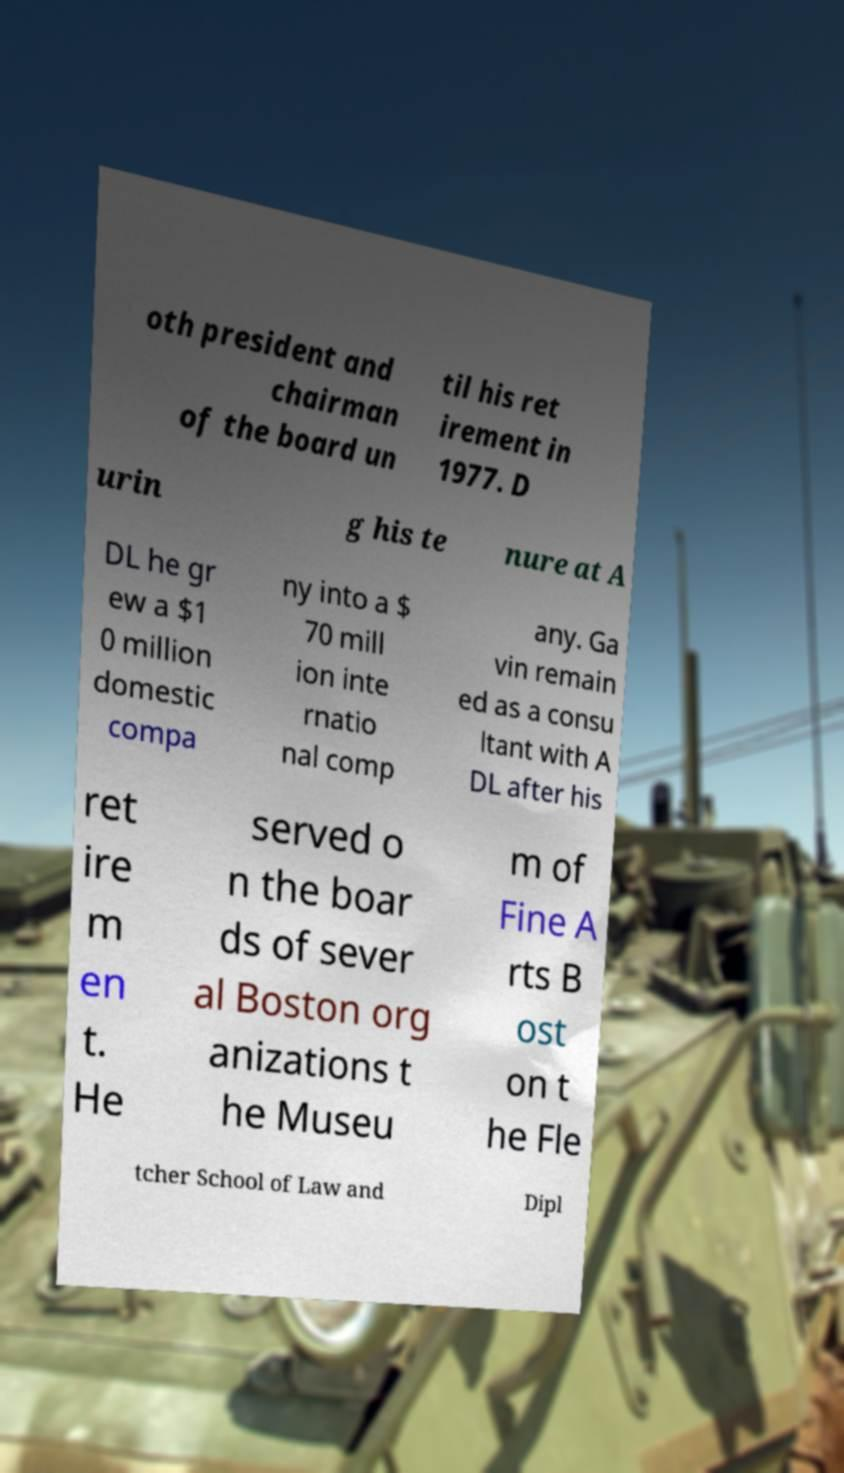There's text embedded in this image that I need extracted. Can you transcribe it verbatim? oth president and chairman of the board un til his ret irement in 1977. D urin g his te nure at A DL he gr ew a $1 0 million domestic compa ny into a $ 70 mill ion inte rnatio nal comp any. Ga vin remain ed as a consu ltant with A DL after his ret ire m en t. He served o n the boar ds of sever al Boston org anizations t he Museu m of Fine A rts B ost on t he Fle tcher School of Law and Dipl 